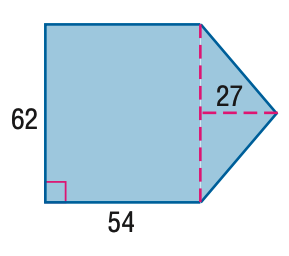Answer the mathemtical geometry problem and directly provide the correct option letter.
Question: Find the area of the figure. Round to the nearest tenth if necessary.
Choices: A: 2511 B: 3348 C: 4185 D: 5022 C 